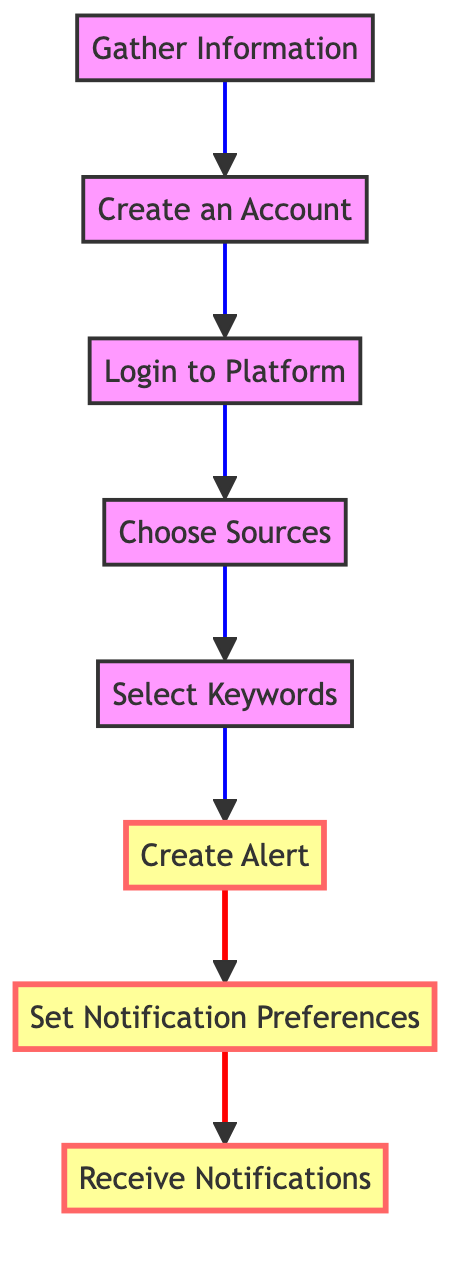What is the first step in the flow chart? The first step in the flow chart is "Gather Information," which is at the bottom of the diagram. This node initiates the process of setting up alerts.
Answer: Gather Information How many nodes are there in total? By counting each step in the flow chart from "Gather Information" to "Receive Notifications," there are a total of 8 nodes.
Answer: 8 What follows the "Create Alert" step? The step that follows "Create Alert" is "Set Notification Preferences," indicating that once an alert is created, the user should adjust their notification settings.
Answer: Set Notification Preferences Which node is marked as a highlight step? The highlighted steps in the flow chart are "Create Alert," "Set Notification Preferences," and "Receive Notifications," indicating their significance in the process.
Answer: Create Alert, Set Notification Preferences, Receive Notifications What does the "Select Keywords" node entail? "Select Keywords" involves choosing specific phrases related to updates about Melanie Walker, guiding the alert's focus.
Answer: Specific keywords How do you begin the process of setting up alerts? You begin the process with "Gather Information," which suggests that collecting details is essential to start setting up alerts.
Answer: Gather Information Which node precedes "Choose Sources"? "Login to Platform" precedes "Choose Sources," meaning that you need to log into your chosen platform before deciding from where to receive updates.
Answer: Login to Platform What is the last step of the process? The last step of the process is "Receive Notifications," which indicates that after setting everything up, one checks for alerts.
Answer: Receive Notifications 